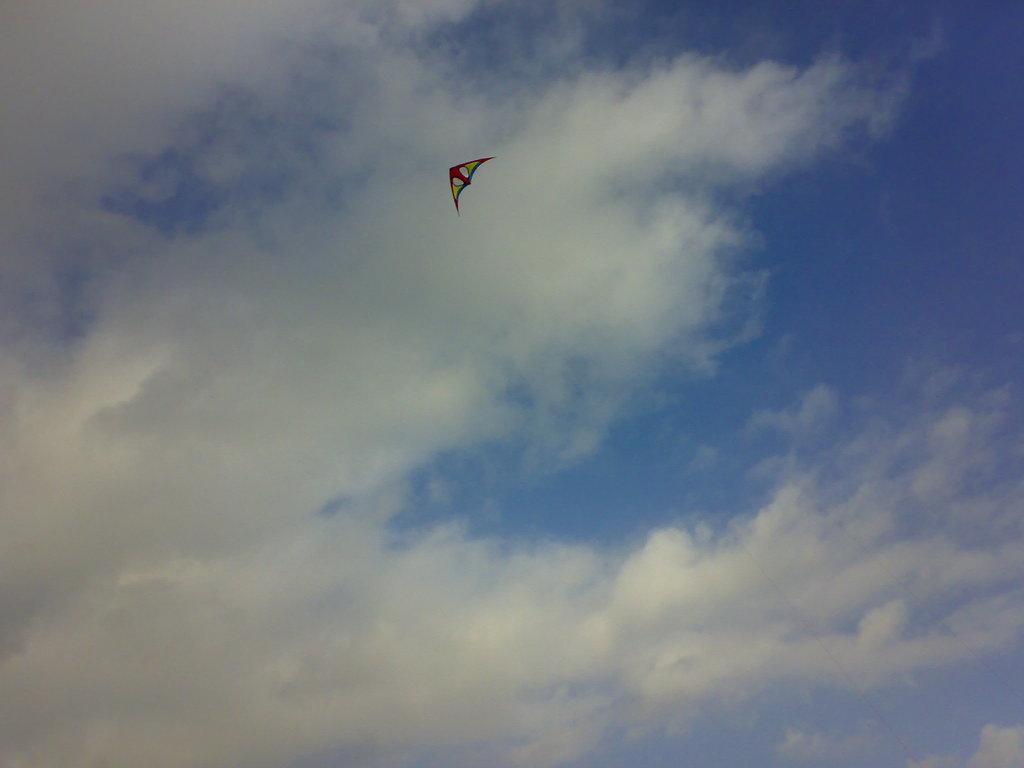In one or two sentences, can you explain what this image depicts? There is a kite. In the background there is sky with clouds. 